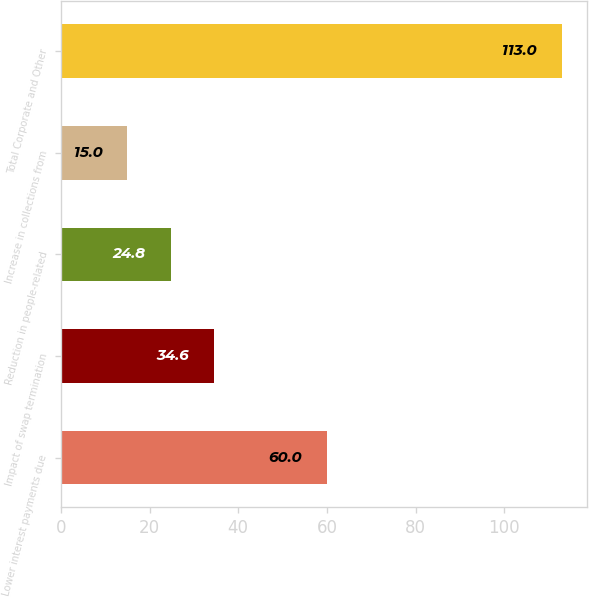<chart> <loc_0><loc_0><loc_500><loc_500><bar_chart><fcel>Lower interest payments due<fcel>Impact of swap termination<fcel>Reduction in people-related<fcel>Increase in collections from<fcel>Total Corporate and Other<nl><fcel>60<fcel>34.6<fcel>24.8<fcel>15<fcel>113<nl></chart> 